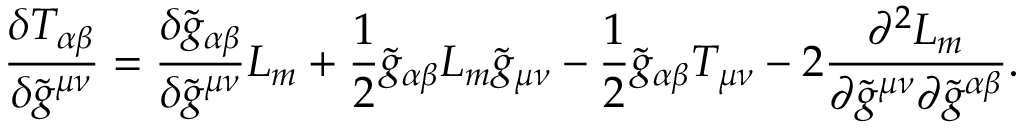Convert formula to latex. <formula><loc_0><loc_0><loc_500><loc_500>\frac { \delta T _ { \alpha \beta } } { \delta \tilde { g } ^ { \mu \nu } } = \frac { \delta \tilde { g } _ { \alpha \beta } } { \delta \tilde { g } ^ { \mu \nu } } L _ { m } + \frac { 1 } { 2 } \tilde { g } _ { \alpha \beta } L _ { m } \tilde { g } _ { \mu \nu } - \frac { 1 } { 2 } \tilde { g } _ { \alpha \beta } T _ { \mu \nu } - 2 \frac { \partial ^ { 2 } L _ { m } } { \partial \tilde { g } ^ { \mu \nu } \partial \tilde { g } ^ { \alpha \beta } } .</formula> 